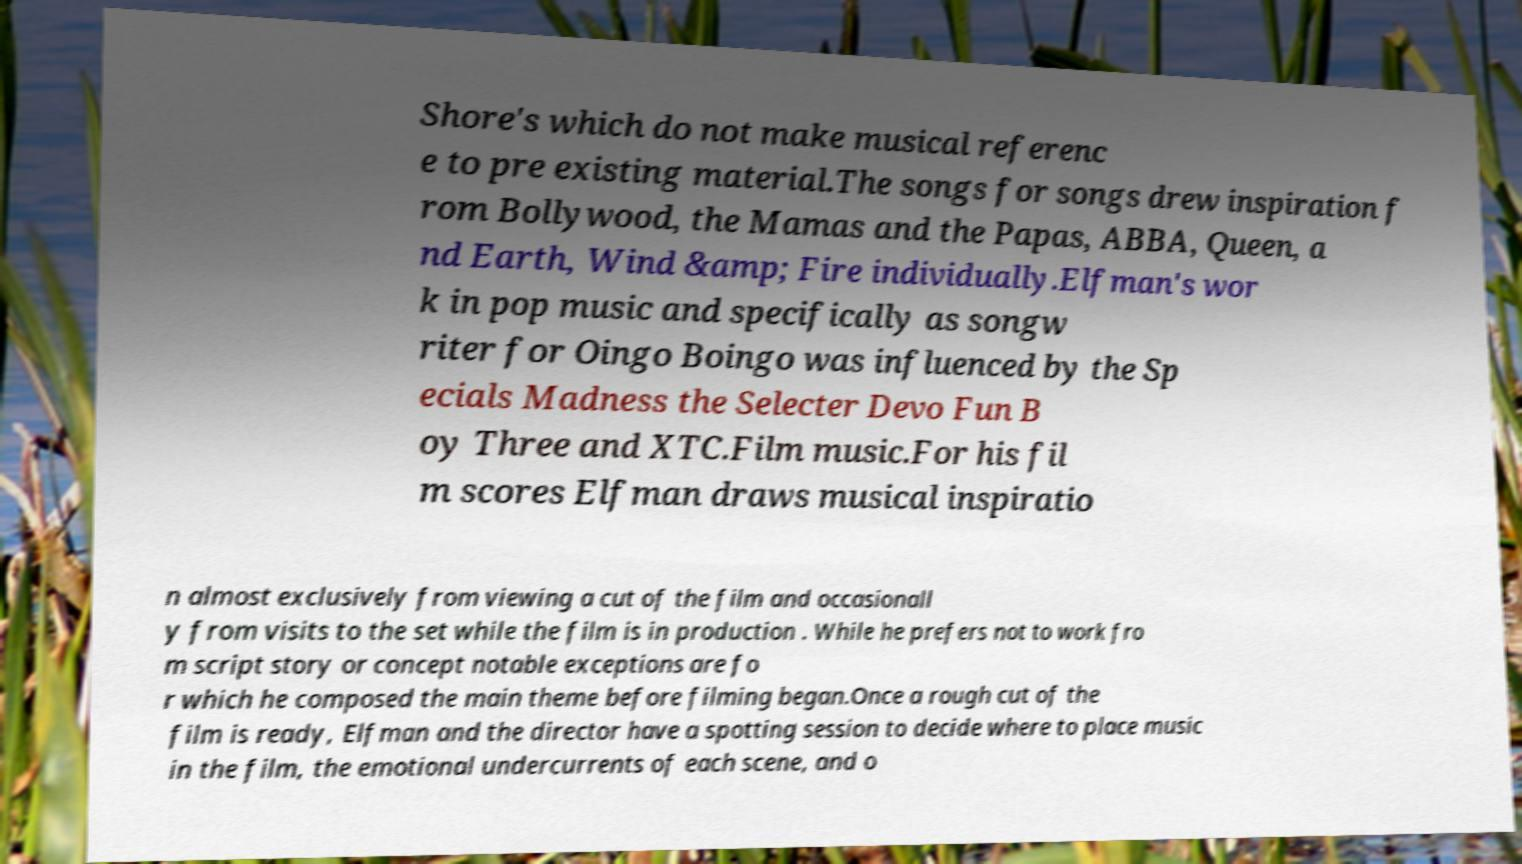There's text embedded in this image that I need extracted. Can you transcribe it verbatim? Shore's which do not make musical referenc e to pre existing material.The songs for songs drew inspiration f rom Bollywood, the Mamas and the Papas, ABBA, Queen, a nd Earth, Wind &amp; Fire individually.Elfman's wor k in pop music and specifically as songw riter for Oingo Boingo was influenced by the Sp ecials Madness the Selecter Devo Fun B oy Three and XTC.Film music.For his fil m scores Elfman draws musical inspiratio n almost exclusively from viewing a cut of the film and occasionall y from visits to the set while the film is in production . While he prefers not to work fro m script story or concept notable exceptions are fo r which he composed the main theme before filming began.Once a rough cut of the film is ready, Elfman and the director have a spotting session to decide where to place music in the film, the emotional undercurrents of each scene, and o 